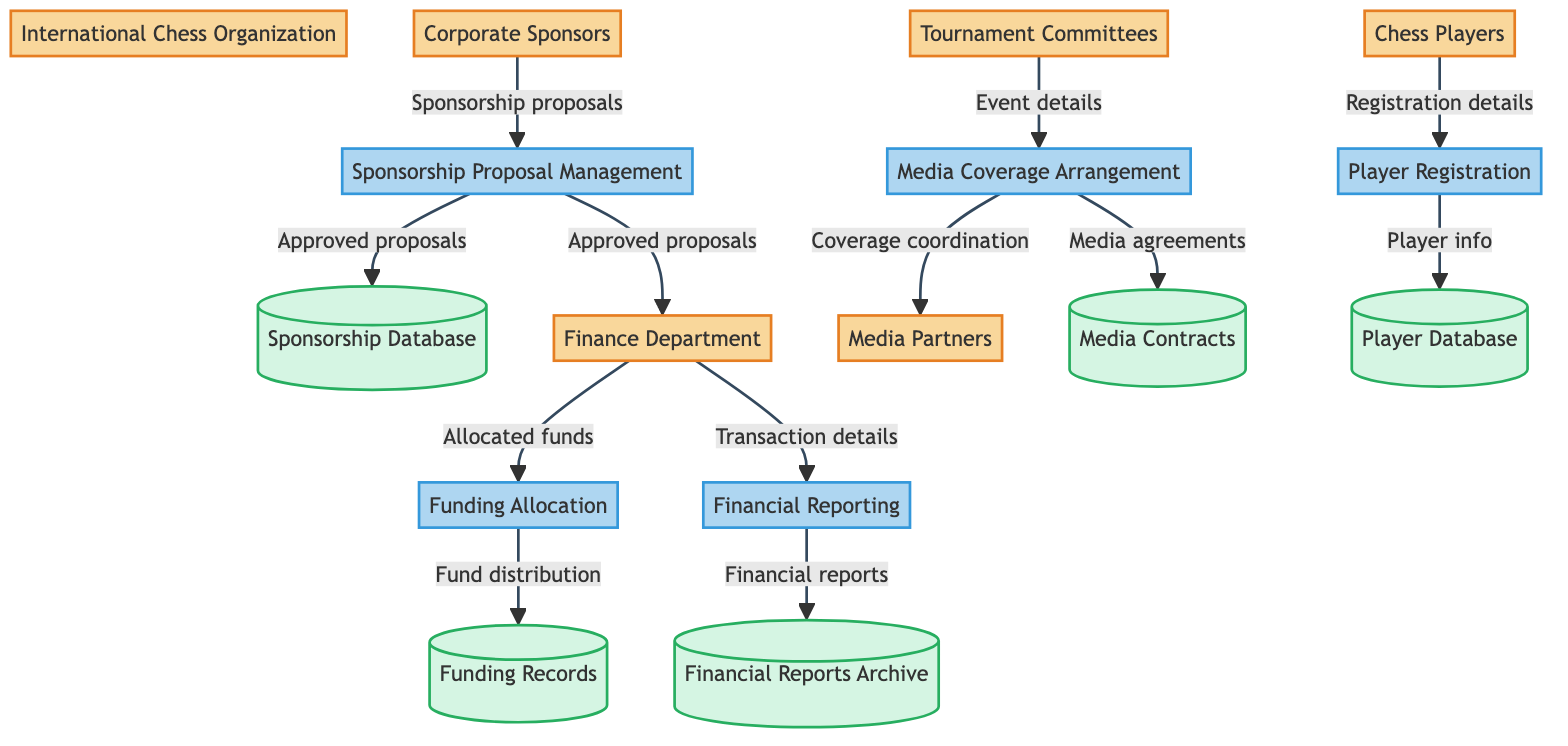What are the entities involved in the sponsorship process? The entities include the International Chess Organization, Corporate Sponsors, Chess Players, Tournament Committees, Finance Department, and Media Partners. These entities are clearly defined in the diagram and contribute to the overall function of the sponsorship process.
Answer: International Chess Organization, Corporate Sponsors, Chess Players, Tournament Committees, Finance Department, Media Partners How many processes are there in the diagram? The diagram lists five specific processes, which are Sponsorship Proposal Management, Funding Allocation, Player Registration, Financial Reporting, and Media Coverage Arrangement. Each process is represented as a separate node in the diagram.
Answer: Five Which entity submits sponsorship proposals? The Corporate Sponsors are the only entity indicated in the diagram that submits sponsorship proposals to the process of Sponsorship Proposal Management. This is a direct connection shown in the data flow.
Answer: Corporate Sponsors What is stored in the Sponsorship Database? The Sponsorship Database holds approved sponsorship proposals and agreements, according to the data flows connecting the Sponsorship Proposal Management process to the Sponsorship Database.
Answer: Approved sponsorship proposals and agreements What does the Finance Department provide to the Financial Reporting process? The Finance Department provides financial transaction details to the Financial Reporting process, as indicated by the data flow labeled "Transaction details" flowing from the Finance Department to Financial Reporting.
Answer: Financial transaction details Which process is responsible for coordinating media coverage? The Media Coverage Arrangement process is responsible for coordinating media coverage, as represented by the direct connection from the Tournament Committees to the Media Coverage Arrangement process in the diagram.
Answer: Media Coverage Arrangement How many distinct data stores are present? There are five distinct data stores in the diagram, including the Sponsorship Database, Funding Records, Player Database, Financial Reports Archive, and Media Contracts. This count includes all unique repositories depicted.
Answer: Five What is the relationship between Funding Allocation and Funding Records? The Funding Allocation process transfers the record of fund distribution to the Funding Records datastore, as indicated by the data flow labeled "Fund distribution." This shows a direct outcome of the Funding Allocation process.
Answer: Record of fund distribution Which data flows from the Player Registration process? The data flow from the Player Registration process is player information which is stored in the Player Database. This is shown in the diagram as a direct flow from Player Registration to Player Database.
Answer: Player information 